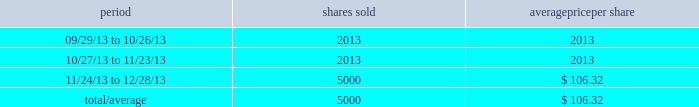Other purchases or sales of equity securities the following chart discloses information regarding shares of snap-on 2019s common stock that were sold by citibank , n.a .
( 201ccitibank 201d ) during the fourth quarter of 2013 pursuant to a prepaid equity forward transaction agreement ( the 201cagreement 201d ) with citibank that is intended to reduce the impact of market risk associated with the stock-based portion of the company 2019s deferred compensation plans .
The company 2019s stock-based deferred compensation liabilities , which are impacted by changes in the company 2019s stock price , increase as the company 2019s stock price rises and decrease as the company 2019s stock price declines .
Pursuant to the agreement , citibank may purchase or sell shares of the company 2019s common stock ( for citibank 2019s account ) in the market or in privately negotiated transactions .
The agreement has no stated expiration date , but the parties expect that each transaction under the agreement will have a term of approximately one year .
The agreement does not provide for snap-on to purchase or repurchase shares .
The following chart discloses information regarding citibank 2019s sales of snap-on common stock during the fourth quarter of 2013 pursuant to the agreement : period shares sold average per share .
2013 annual report 23 .
What is the total cash received from the sales of common stock during the 4th quarter of 2013? 
Computations: (5000 * 106.32)
Answer: 531600.0. 